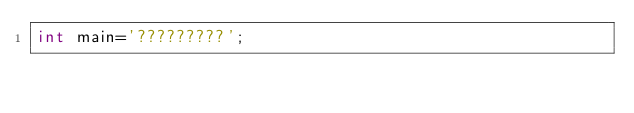Convert code to text. <code><loc_0><loc_0><loc_500><loc_500><_C_>int main='?????????';</code> 